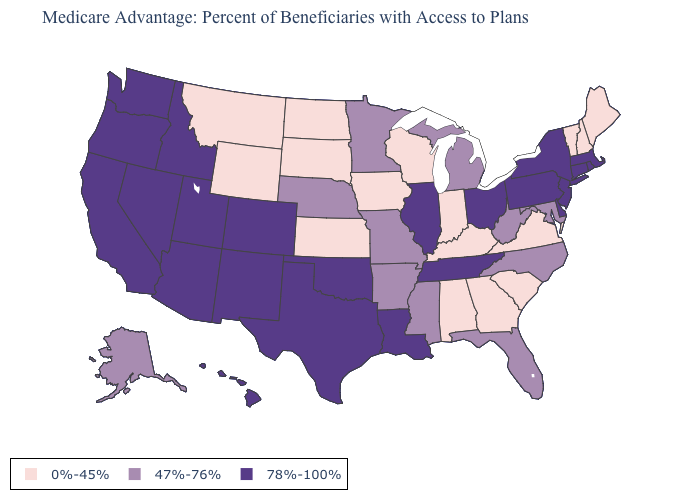Among the states that border Louisiana , which have the lowest value?
Write a very short answer. Arkansas, Mississippi. How many symbols are there in the legend?
Give a very brief answer. 3. Does the first symbol in the legend represent the smallest category?
Concise answer only. Yes. What is the value of Ohio?
Answer briefly. 78%-100%. What is the lowest value in the MidWest?
Short answer required. 0%-45%. Among the states that border Arizona , which have the highest value?
Answer briefly. California, Colorado, New Mexico, Nevada, Utah. Does Wyoming have the lowest value in the USA?
Keep it brief. Yes. Does North Carolina have a higher value than Colorado?
Short answer required. No. Which states have the highest value in the USA?
Write a very short answer. Arizona, California, Colorado, Connecticut, Delaware, Hawaii, Idaho, Illinois, Louisiana, Massachusetts, New Jersey, New Mexico, Nevada, New York, Ohio, Oklahoma, Oregon, Pennsylvania, Rhode Island, Tennessee, Texas, Utah, Washington. What is the highest value in states that border Idaho?
Answer briefly. 78%-100%. Which states have the lowest value in the MidWest?
Answer briefly. Iowa, Indiana, Kansas, North Dakota, South Dakota, Wisconsin. Which states have the lowest value in the South?
Quick response, please. Alabama, Georgia, Kentucky, South Carolina, Virginia. Name the states that have a value in the range 0%-45%?
Short answer required. Alabama, Georgia, Iowa, Indiana, Kansas, Kentucky, Maine, Montana, North Dakota, New Hampshire, South Carolina, South Dakota, Virginia, Vermont, Wisconsin, Wyoming. Does the map have missing data?
Give a very brief answer. No. 